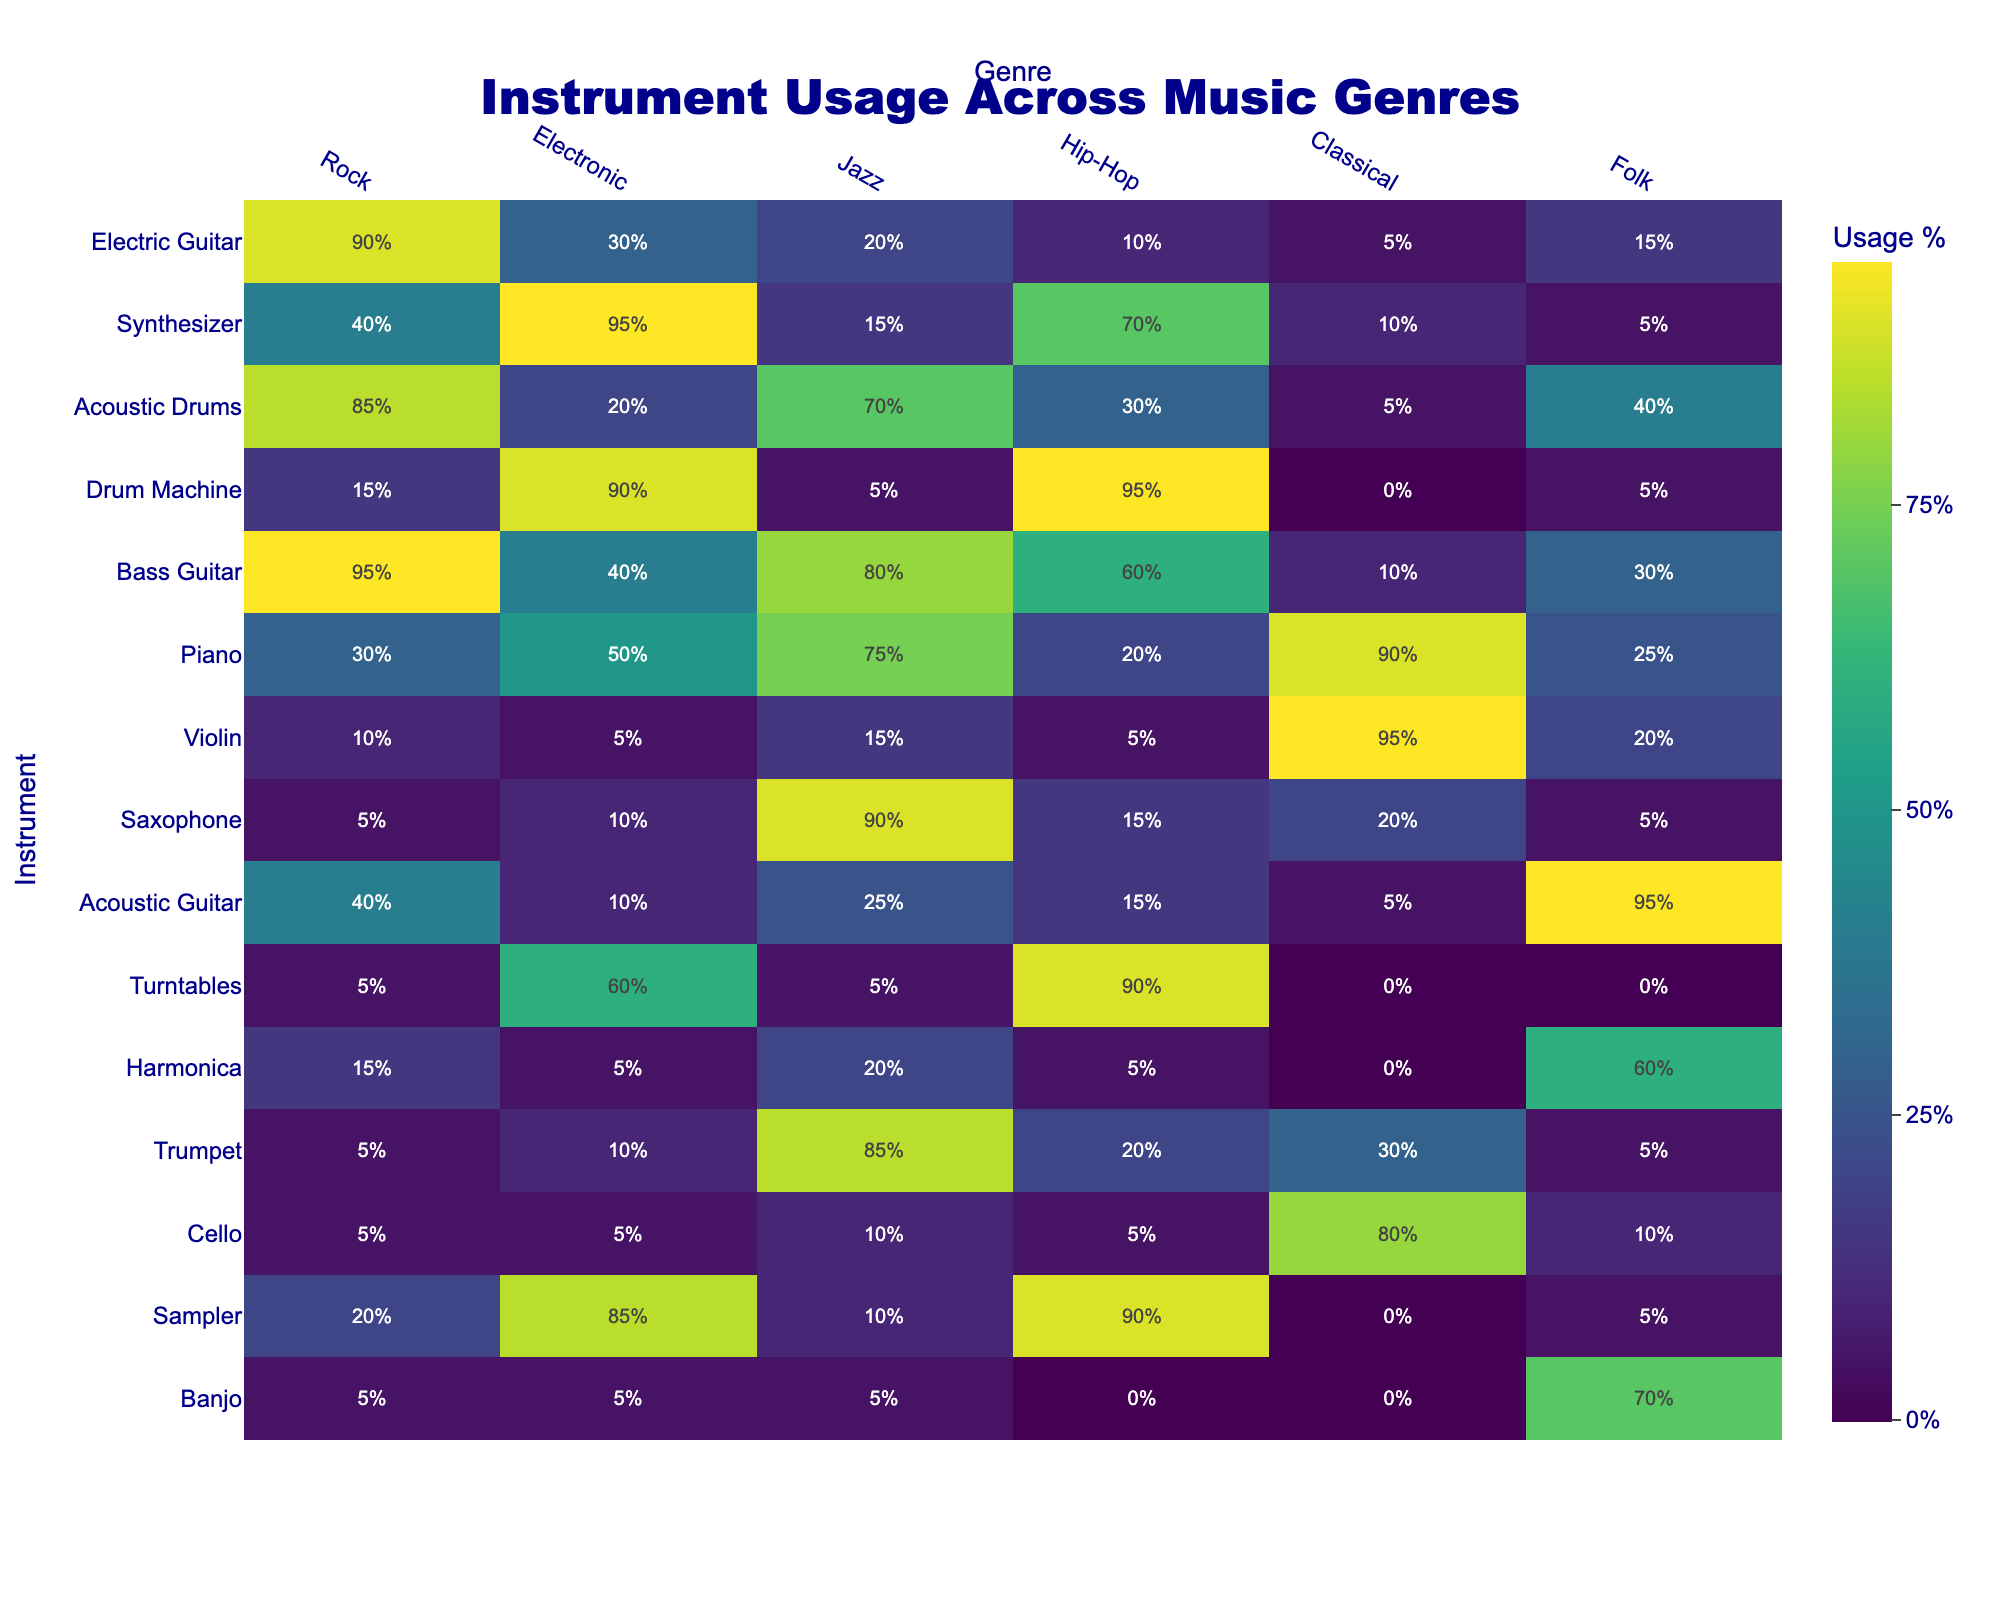What instrument is most used in Rock music? Looking at the Rock column, Electric Guitar has the highest usage at 90%.
Answer: Electric Guitar Which instrument is used the least in Electronic music? Checking the Electronic column, the instrument with the least usage is Acoustic Guitar at 10%.
Answer: Acoustic Guitar What is the percentage of Electric Guitar usage in Folk music? In the Folk column under Electric Guitar, the usage is noted as 15%.
Answer: 15% Which genre uses Drum Machine the most? The Drum Machine has the highest percentage usage in Hip-Hop at 95%.
Answer: Hip-Hop What instrument has the highest percentage usage in Jazz music? In the Jazz column, the instrument with the highest usage is Saxophone at 90%.
Answer: Saxophone Is there any instrument that has a 0% usage in Classical music? Looking through the Classical column, the Drum Machine and Turntables show a 0% usage.
Answer: Yes What is the average usage percentage of the Piano across all genres? The Piano percentages are 30%, 50%, 75%, 20%, 90%, and 25%. Adding these gives 290%, dividing by 6 yields an average of approximately 48.33%.
Answer: Approximately 48% Which two genres have the most similar usage percentages for Bass Guitar? The Bass Guitar usage percentages are 95% for Rock and 80% for Jazz, which are the closest values on inspection.
Answer: Rock and Jazz How many genres have more than 50% usage of the Synthesizer? The usage of the Synthesizer is above 50% in Electronic (95%), Hip-Hop (70%), and Jazz (15%). Thus, there are 2 genres (Electronic and Hip-Hop) with more than 50%.
Answer: 2 What is the difference in usage percentage of Acoustic Drums between Rock and Jazz? The usage for Acoustic Drums is 85% in Rock and 70% in Jazz. The difference is 85% - 70% = 15%.
Answer: 15% Which instrument is least utilized in Folk music? In the Folk column, the instrument with the least percentage is the Turntables at 0%.
Answer: Turntables What genre uses the Cello the most compared to others? The Cello is used the most in Classical music with a usage percentage of 80%, compared with 10% or lower in other genres.
Answer: Classical What percentage of Acoustic Guitar usage is higher than 20%? The Acoustic Guitar shows 25% usage in Hip-Hop and 95% in Folk; both are above 20%.
Answer: 2 genres What instrument is common to both Jazz and Classical music but not as prominent? The Violin is used in Jazz (15%) and significantly in Classical (95%), making it noteworthy but not prominent.
Answer: Violin 